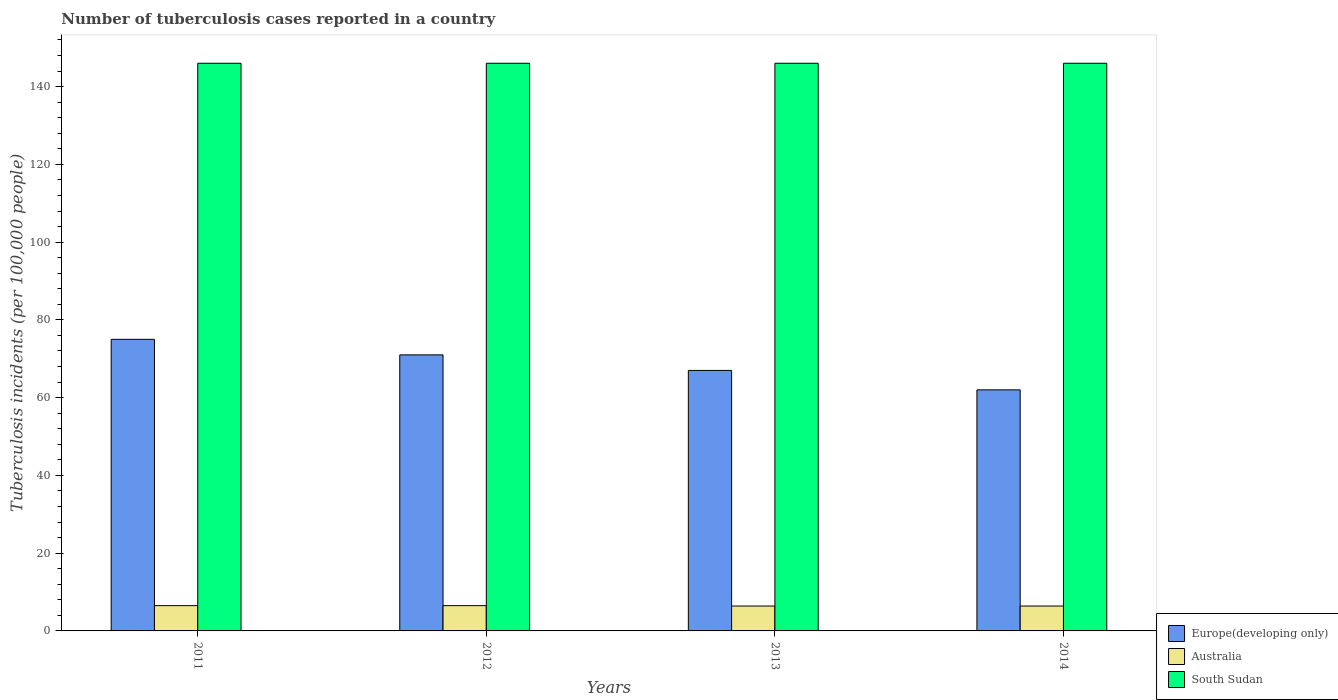How many different coloured bars are there?
Provide a short and direct response. 3. How many groups of bars are there?
Offer a very short reply. 4. Are the number of bars per tick equal to the number of legend labels?
Make the answer very short. Yes. Are the number of bars on each tick of the X-axis equal?
Your response must be concise. Yes. How many bars are there on the 4th tick from the left?
Your answer should be compact. 3. What is the label of the 3rd group of bars from the left?
Make the answer very short. 2013. In how many cases, is the number of bars for a given year not equal to the number of legend labels?
Provide a succinct answer. 0. What is the number of tuberculosis cases reported in in Europe(developing only) in 2011?
Make the answer very short. 75. Across all years, what is the maximum number of tuberculosis cases reported in in Europe(developing only)?
Provide a succinct answer. 75. Across all years, what is the minimum number of tuberculosis cases reported in in South Sudan?
Give a very brief answer. 146. In which year was the number of tuberculosis cases reported in in South Sudan minimum?
Offer a very short reply. 2011. What is the total number of tuberculosis cases reported in in South Sudan in the graph?
Offer a terse response. 584. What is the difference between the number of tuberculosis cases reported in in Europe(developing only) in 2012 and that in 2014?
Your response must be concise. 9. What is the difference between the number of tuberculosis cases reported in in Australia in 2012 and the number of tuberculosis cases reported in in Europe(developing only) in 2013?
Provide a short and direct response. -60.5. What is the average number of tuberculosis cases reported in in Europe(developing only) per year?
Your answer should be very brief. 68.75. In the year 2013, what is the difference between the number of tuberculosis cases reported in in Europe(developing only) and number of tuberculosis cases reported in in Australia?
Your answer should be compact. 60.6. In how many years, is the number of tuberculosis cases reported in in Europe(developing only) greater than 28?
Your answer should be compact. 4. What is the ratio of the number of tuberculosis cases reported in in Europe(developing only) in 2011 to that in 2012?
Offer a terse response. 1.06. What is the difference between the highest and the lowest number of tuberculosis cases reported in in South Sudan?
Offer a terse response. 0. In how many years, is the number of tuberculosis cases reported in in South Sudan greater than the average number of tuberculosis cases reported in in South Sudan taken over all years?
Keep it short and to the point. 0. Is the sum of the number of tuberculosis cases reported in in Europe(developing only) in 2011 and 2012 greater than the maximum number of tuberculosis cases reported in in Australia across all years?
Give a very brief answer. Yes. What does the 1st bar from the left in 2012 represents?
Offer a terse response. Europe(developing only). What does the 3rd bar from the right in 2011 represents?
Ensure brevity in your answer.  Europe(developing only). Is it the case that in every year, the sum of the number of tuberculosis cases reported in in Europe(developing only) and number of tuberculosis cases reported in in Australia is greater than the number of tuberculosis cases reported in in South Sudan?
Offer a very short reply. No. What is the difference between two consecutive major ticks on the Y-axis?
Ensure brevity in your answer.  20. Does the graph contain grids?
Make the answer very short. No. Where does the legend appear in the graph?
Offer a terse response. Bottom right. How many legend labels are there?
Keep it short and to the point. 3. How are the legend labels stacked?
Ensure brevity in your answer.  Vertical. What is the title of the graph?
Give a very brief answer. Number of tuberculosis cases reported in a country. Does "Rwanda" appear as one of the legend labels in the graph?
Provide a short and direct response. No. What is the label or title of the Y-axis?
Make the answer very short. Tuberculosis incidents (per 100,0 people). What is the Tuberculosis incidents (per 100,000 people) in Australia in 2011?
Ensure brevity in your answer.  6.5. What is the Tuberculosis incidents (per 100,000 people) of South Sudan in 2011?
Keep it short and to the point. 146. What is the Tuberculosis incidents (per 100,000 people) in Europe(developing only) in 2012?
Your answer should be very brief. 71. What is the Tuberculosis incidents (per 100,000 people) in South Sudan in 2012?
Your response must be concise. 146. What is the Tuberculosis incidents (per 100,000 people) of South Sudan in 2013?
Keep it short and to the point. 146. What is the Tuberculosis incidents (per 100,000 people) of Europe(developing only) in 2014?
Make the answer very short. 62. What is the Tuberculosis incidents (per 100,000 people) of Australia in 2014?
Ensure brevity in your answer.  6.4. What is the Tuberculosis incidents (per 100,000 people) of South Sudan in 2014?
Provide a succinct answer. 146. Across all years, what is the maximum Tuberculosis incidents (per 100,000 people) in South Sudan?
Give a very brief answer. 146. Across all years, what is the minimum Tuberculosis incidents (per 100,000 people) in Europe(developing only)?
Keep it short and to the point. 62. Across all years, what is the minimum Tuberculosis incidents (per 100,000 people) of South Sudan?
Give a very brief answer. 146. What is the total Tuberculosis incidents (per 100,000 people) in Europe(developing only) in the graph?
Give a very brief answer. 275. What is the total Tuberculosis incidents (per 100,000 people) of Australia in the graph?
Your response must be concise. 25.8. What is the total Tuberculosis incidents (per 100,000 people) of South Sudan in the graph?
Offer a terse response. 584. What is the difference between the Tuberculosis incidents (per 100,000 people) of Europe(developing only) in 2011 and that in 2012?
Keep it short and to the point. 4. What is the difference between the Tuberculosis incidents (per 100,000 people) of Australia in 2011 and that in 2013?
Provide a succinct answer. 0.1. What is the difference between the Tuberculosis incidents (per 100,000 people) of South Sudan in 2011 and that in 2013?
Offer a terse response. 0. What is the difference between the Tuberculosis incidents (per 100,000 people) in Europe(developing only) in 2011 and that in 2014?
Keep it short and to the point. 13. What is the difference between the Tuberculosis incidents (per 100,000 people) in Australia in 2011 and that in 2014?
Ensure brevity in your answer.  0.1. What is the difference between the Tuberculosis incidents (per 100,000 people) of Australia in 2012 and that in 2013?
Keep it short and to the point. 0.1. What is the difference between the Tuberculosis incidents (per 100,000 people) of South Sudan in 2012 and that in 2013?
Keep it short and to the point. 0. What is the difference between the Tuberculosis incidents (per 100,000 people) of Australia in 2012 and that in 2014?
Offer a terse response. 0.1. What is the difference between the Tuberculosis incidents (per 100,000 people) of Australia in 2013 and that in 2014?
Your answer should be very brief. 0. What is the difference between the Tuberculosis incidents (per 100,000 people) of South Sudan in 2013 and that in 2014?
Offer a very short reply. 0. What is the difference between the Tuberculosis incidents (per 100,000 people) of Europe(developing only) in 2011 and the Tuberculosis incidents (per 100,000 people) of Australia in 2012?
Provide a succinct answer. 68.5. What is the difference between the Tuberculosis incidents (per 100,000 people) in Europe(developing only) in 2011 and the Tuberculosis incidents (per 100,000 people) in South Sudan in 2012?
Ensure brevity in your answer.  -71. What is the difference between the Tuberculosis incidents (per 100,000 people) of Australia in 2011 and the Tuberculosis incidents (per 100,000 people) of South Sudan in 2012?
Make the answer very short. -139.5. What is the difference between the Tuberculosis incidents (per 100,000 people) in Europe(developing only) in 2011 and the Tuberculosis incidents (per 100,000 people) in Australia in 2013?
Give a very brief answer. 68.6. What is the difference between the Tuberculosis incidents (per 100,000 people) of Europe(developing only) in 2011 and the Tuberculosis incidents (per 100,000 people) of South Sudan in 2013?
Give a very brief answer. -71. What is the difference between the Tuberculosis incidents (per 100,000 people) of Australia in 2011 and the Tuberculosis incidents (per 100,000 people) of South Sudan in 2013?
Give a very brief answer. -139.5. What is the difference between the Tuberculosis incidents (per 100,000 people) of Europe(developing only) in 2011 and the Tuberculosis incidents (per 100,000 people) of Australia in 2014?
Your answer should be very brief. 68.6. What is the difference between the Tuberculosis incidents (per 100,000 people) in Europe(developing only) in 2011 and the Tuberculosis incidents (per 100,000 people) in South Sudan in 2014?
Keep it short and to the point. -71. What is the difference between the Tuberculosis incidents (per 100,000 people) of Australia in 2011 and the Tuberculosis incidents (per 100,000 people) of South Sudan in 2014?
Your answer should be very brief. -139.5. What is the difference between the Tuberculosis incidents (per 100,000 people) of Europe(developing only) in 2012 and the Tuberculosis incidents (per 100,000 people) of Australia in 2013?
Offer a terse response. 64.6. What is the difference between the Tuberculosis incidents (per 100,000 people) of Europe(developing only) in 2012 and the Tuberculosis incidents (per 100,000 people) of South Sudan in 2013?
Give a very brief answer. -75. What is the difference between the Tuberculosis incidents (per 100,000 people) in Australia in 2012 and the Tuberculosis incidents (per 100,000 people) in South Sudan in 2013?
Your response must be concise. -139.5. What is the difference between the Tuberculosis incidents (per 100,000 people) in Europe(developing only) in 2012 and the Tuberculosis incidents (per 100,000 people) in Australia in 2014?
Give a very brief answer. 64.6. What is the difference between the Tuberculosis incidents (per 100,000 people) of Europe(developing only) in 2012 and the Tuberculosis incidents (per 100,000 people) of South Sudan in 2014?
Provide a short and direct response. -75. What is the difference between the Tuberculosis incidents (per 100,000 people) of Australia in 2012 and the Tuberculosis incidents (per 100,000 people) of South Sudan in 2014?
Your answer should be compact. -139.5. What is the difference between the Tuberculosis incidents (per 100,000 people) of Europe(developing only) in 2013 and the Tuberculosis incidents (per 100,000 people) of Australia in 2014?
Your response must be concise. 60.6. What is the difference between the Tuberculosis incidents (per 100,000 people) of Europe(developing only) in 2013 and the Tuberculosis incidents (per 100,000 people) of South Sudan in 2014?
Give a very brief answer. -79. What is the difference between the Tuberculosis incidents (per 100,000 people) of Australia in 2013 and the Tuberculosis incidents (per 100,000 people) of South Sudan in 2014?
Provide a succinct answer. -139.6. What is the average Tuberculosis incidents (per 100,000 people) of Europe(developing only) per year?
Your response must be concise. 68.75. What is the average Tuberculosis incidents (per 100,000 people) in Australia per year?
Ensure brevity in your answer.  6.45. What is the average Tuberculosis incidents (per 100,000 people) of South Sudan per year?
Make the answer very short. 146. In the year 2011, what is the difference between the Tuberculosis incidents (per 100,000 people) of Europe(developing only) and Tuberculosis incidents (per 100,000 people) of Australia?
Your answer should be compact. 68.5. In the year 2011, what is the difference between the Tuberculosis incidents (per 100,000 people) of Europe(developing only) and Tuberculosis incidents (per 100,000 people) of South Sudan?
Give a very brief answer. -71. In the year 2011, what is the difference between the Tuberculosis incidents (per 100,000 people) in Australia and Tuberculosis incidents (per 100,000 people) in South Sudan?
Ensure brevity in your answer.  -139.5. In the year 2012, what is the difference between the Tuberculosis incidents (per 100,000 people) in Europe(developing only) and Tuberculosis incidents (per 100,000 people) in Australia?
Your answer should be compact. 64.5. In the year 2012, what is the difference between the Tuberculosis incidents (per 100,000 people) in Europe(developing only) and Tuberculosis incidents (per 100,000 people) in South Sudan?
Make the answer very short. -75. In the year 2012, what is the difference between the Tuberculosis incidents (per 100,000 people) of Australia and Tuberculosis incidents (per 100,000 people) of South Sudan?
Give a very brief answer. -139.5. In the year 2013, what is the difference between the Tuberculosis incidents (per 100,000 people) of Europe(developing only) and Tuberculosis incidents (per 100,000 people) of Australia?
Your response must be concise. 60.6. In the year 2013, what is the difference between the Tuberculosis incidents (per 100,000 people) of Europe(developing only) and Tuberculosis incidents (per 100,000 people) of South Sudan?
Give a very brief answer. -79. In the year 2013, what is the difference between the Tuberculosis incidents (per 100,000 people) in Australia and Tuberculosis incidents (per 100,000 people) in South Sudan?
Your answer should be compact. -139.6. In the year 2014, what is the difference between the Tuberculosis incidents (per 100,000 people) of Europe(developing only) and Tuberculosis incidents (per 100,000 people) of Australia?
Provide a short and direct response. 55.6. In the year 2014, what is the difference between the Tuberculosis incidents (per 100,000 people) in Europe(developing only) and Tuberculosis incidents (per 100,000 people) in South Sudan?
Your response must be concise. -84. In the year 2014, what is the difference between the Tuberculosis incidents (per 100,000 people) of Australia and Tuberculosis incidents (per 100,000 people) of South Sudan?
Offer a very short reply. -139.6. What is the ratio of the Tuberculosis incidents (per 100,000 people) of Europe(developing only) in 2011 to that in 2012?
Give a very brief answer. 1.06. What is the ratio of the Tuberculosis incidents (per 100,000 people) of Australia in 2011 to that in 2012?
Your answer should be compact. 1. What is the ratio of the Tuberculosis incidents (per 100,000 people) of Europe(developing only) in 2011 to that in 2013?
Your answer should be compact. 1.12. What is the ratio of the Tuberculosis incidents (per 100,000 people) of Australia in 2011 to that in 2013?
Offer a very short reply. 1.02. What is the ratio of the Tuberculosis incidents (per 100,000 people) in South Sudan in 2011 to that in 2013?
Make the answer very short. 1. What is the ratio of the Tuberculosis incidents (per 100,000 people) in Europe(developing only) in 2011 to that in 2014?
Offer a very short reply. 1.21. What is the ratio of the Tuberculosis incidents (per 100,000 people) of Australia in 2011 to that in 2014?
Give a very brief answer. 1.02. What is the ratio of the Tuberculosis incidents (per 100,000 people) of Europe(developing only) in 2012 to that in 2013?
Your answer should be compact. 1.06. What is the ratio of the Tuberculosis incidents (per 100,000 people) of Australia in 2012 to that in 2013?
Keep it short and to the point. 1.02. What is the ratio of the Tuberculosis incidents (per 100,000 people) of South Sudan in 2012 to that in 2013?
Your response must be concise. 1. What is the ratio of the Tuberculosis incidents (per 100,000 people) in Europe(developing only) in 2012 to that in 2014?
Provide a succinct answer. 1.15. What is the ratio of the Tuberculosis incidents (per 100,000 people) of Australia in 2012 to that in 2014?
Your answer should be compact. 1.02. What is the ratio of the Tuberculosis incidents (per 100,000 people) of Europe(developing only) in 2013 to that in 2014?
Ensure brevity in your answer.  1.08. What is the ratio of the Tuberculosis incidents (per 100,000 people) of South Sudan in 2013 to that in 2014?
Ensure brevity in your answer.  1. What is the difference between the highest and the second highest Tuberculosis incidents (per 100,000 people) of Europe(developing only)?
Provide a succinct answer. 4. What is the difference between the highest and the second highest Tuberculosis incidents (per 100,000 people) of South Sudan?
Provide a short and direct response. 0. What is the difference between the highest and the lowest Tuberculosis incidents (per 100,000 people) of Europe(developing only)?
Give a very brief answer. 13. What is the difference between the highest and the lowest Tuberculosis incidents (per 100,000 people) of South Sudan?
Your response must be concise. 0. 